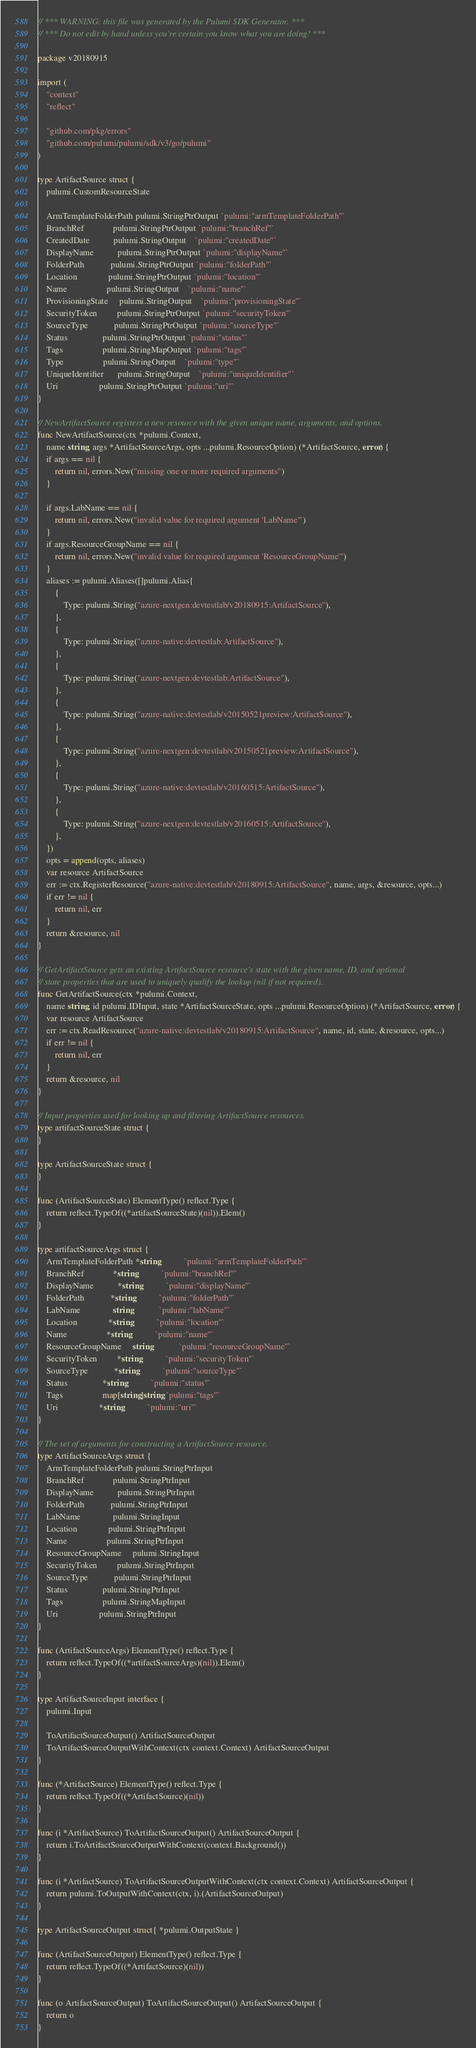<code> <loc_0><loc_0><loc_500><loc_500><_Go_>// *** WARNING: this file was generated by the Pulumi SDK Generator. ***
// *** Do not edit by hand unless you're certain you know what you are doing! ***

package v20180915

import (
	"context"
	"reflect"

	"github.com/pkg/errors"
	"github.com/pulumi/pulumi/sdk/v3/go/pulumi"
)

type ArtifactSource struct {
	pulumi.CustomResourceState

	ArmTemplateFolderPath pulumi.StringPtrOutput `pulumi:"armTemplateFolderPath"`
	BranchRef             pulumi.StringPtrOutput `pulumi:"branchRef"`
	CreatedDate           pulumi.StringOutput    `pulumi:"createdDate"`
	DisplayName           pulumi.StringPtrOutput `pulumi:"displayName"`
	FolderPath            pulumi.StringPtrOutput `pulumi:"folderPath"`
	Location              pulumi.StringPtrOutput `pulumi:"location"`
	Name                  pulumi.StringOutput    `pulumi:"name"`
	ProvisioningState     pulumi.StringOutput    `pulumi:"provisioningState"`
	SecurityToken         pulumi.StringPtrOutput `pulumi:"securityToken"`
	SourceType            pulumi.StringPtrOutput `pulumi:"sourceType"`
	Status                pulumi.StringPtrOutput `pulumi:"status"`
	Tags                  pulumi.StringMapOutput `pulumi:"tags"`
	Type                  pulumi.StringOutput    `pulumi:"type"`
	UniqueIdentifier      pulumi.StringOutput    `pulumi:"uniqueIdentifier"`
	Uri                   pulumi.StringPtrOutput `pulumi:"uri"`
}

// NewArtifactSource registers a new resource with the given unique name, arguments, and options.
func NewArtifactSource(ctx *pulumi.Context,
	name string, args *ArtifactSourceArgs, opts ...pulumi.ResourceOption) (*ArtifactSource, error) {
	if args == nil {
		return nil, errors.New("missing one or more required arguments")
	}

	if args.LabName == nil {
		return nil, errors.New("invalid value for required argument 'LabName'")
	}
	if args.ResourceGroupName == nil {
		return nil, errors.New("invalid value for required argument 'ResourceGroupName'")
	}
	aliases := pulumi.Aliases([]pulumi.Alias{
		{
			Type: pulumi.String("azure-nextgen:devtestlab/v20180915:ArtifactSource"),
		},
		{
			Type: pulumi.String("azure-native:devtestlab:ArtifactSource"),
		},
		{
			Type: pulumi.String("azure-nextgen:devtestlab:ArtifactSource"),
		},
		{
			Type: pulumi.String("azure-native:devtestlab/v20150521preview:ArtifactSource"),
		},
		{
			Type: pulumi.String("azure-nextgen:devtestlab/v20150521preview:ArtifactSource"),
		},
		{
			Type: pulumi.String("azure-native:devtestlab/v20160515:ArtifactSource"),
		},
		{
			Type: pulumi.String("azure-nextgen:devtestlab/v20160515:ArtifactSource"),
		},
	})
	opts = append(opts, aliases)
	var resource ArtifactSource
	err := ctx.RegisterResource("azure-native:devtestlab/v20180915:ArtifactSource", name, args, &resource, opts...)
	if err != nil {
		return nil, err
	}
	return &resource, nil
}

// GetArtifactSource gets an existing ArtifactSource resource's state with the given name, ID, and optional
// state properties that are used to uniquely qualify the lookup (nil if not required).
func GetArtifactSource(ctx *pulumi.Context,
	name string, id pulumi.IDInput, state *ArtifactSourceState, opts ...pulumi.ResourceOption) (*ArtifactSource, error) {
	var resource ArtifactSource
	err := ctx.ReadResource("azure-native:devtestlab/v20180915:ArtifactSource", name, id, state, &resource, opts...)
	if err != nil {
		return nil, err
	}
	return &resource, nil
}

// Input properties used for looking up and filtering ArtifactSource resources.
type artifactSourceState struct {
}

type ArtifactSourceState struct {
}

func (ArtifactSourceState) ElementType() reflect.Type {
	return reflect.TypeOf((*artifactSourceState)(nil)).Elem()
}

type artifactSourceArgs struct {
	ArmTemplateFolderPath *string           `pulumi:"armTemplateFolderPath"`
	BranchRef             *string           `pulumi:"branchRef"`
	DisplayName           *string           `pulumi:"displayName"`
	FolderPath            *string           `pulumi:"folderPath"`
	LabName               string            `pulumi:"labName"`
	Location              *string           `pulumi:"location"`
	Name                  *string           `pulumi:"name"`
	ResourceGroupName     string            `pulumi:"resourceGroupName"`
	SecurityToken         *string           `pulumi:"securityToken"`
	SourceType            *string           `pulumi:"sourceType"`
	Status                *string           `pulumi:"status"`
	Tags                  map[string]string `pulumi:"tags"`
	Uri                   *string           `pulumi:"uri"`
}

// The set of arguments for constructing a ArtifactSource resource.
type ArtifactSourceArgs struct {
	ArmTemplateFolderPath pulumi.StringPtrInput
	BranchRef             pulumi.StringPtrInput
	DisplayName           pulumi.StringPtrInput
	FolderPath            pulumi.StringPtrInput
	LabName               pulumi.StringInput
	Location              pulumi.StringPtrInput
	Name                  pulumi.StringPtrInput
	ResourceGroupName     pulumi.StringInput
	SecurityToken         pulumi.StringPtrInput
	SourceType            pulumi.StringPtrInput
	Status                pulumi.StringPtrInput
	Tags                  pulumi.StringMapInput
	Uri                   pulumi.StringPtrInput
}

func (ArtifactSourceArgs) ElementType() reflect.Type {
	return reflect.TypeOf((*artifactSourceArgs)(nil)).Elem()
}

type ArtifactSourceInput interface {
	pulumi.Input

	ToArtifactSourceOutput() ArtifactSourceOutput
	ToArtifactSourceOutputWithContext(ctx context.Context) ArtifactSourceOutput
}

func (*ArtifactSource) ElementType() reflect.Type {
	return reflect.TypeOf((*ArtifactSource)(nil))
}

func (i *ArtifactSource) ToArtifactSourceOutput() ArtifactSourceOutput {
	return i.ToArtifactSourceOutputWithContext(context.Background())
}

func (i *ArtifactSource) ToArtifactSourceOutputWithContext(ctx context.Context) ArtifactSourceOutput {
	return pulumi.ToOutputWithContext(ctx, i).(ArtifactSourceOutput)
}

type ArtifactSourceOutput struct{ *pulumi.OutputState }

func (ArtifactSourceOutput) ElementType() reflect.Type {
	return reflect.TypeOf((*ArtifactSource)(nil))
}

func (o ArtifactSourceOutput) ToArtifactSourceOutput() ArtifactSourceOutput {
	return o
}
</code> 